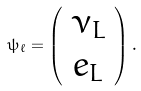Convert formula to latex. <formula><loc_0><loc_0><loc_500><loc_500>\psi _ { \ell } = \left ( \begin{array} { c } \nu _ { L } \\ e _ { L } \end{array} \right ) .</formula> 